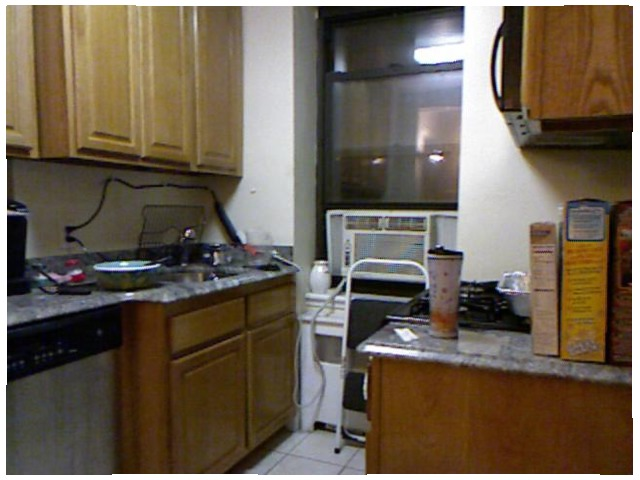<image>
Is the cup in front of the stove? Yes. The cup is positioned in front of the stove, appearing closer to the camera viewpoint. Is there a step stool in front of the ac unit? Yes. The step stool is positioned in front of the ac unit, appearing closer to the camera viewpoint. Is the cabinet to the left of the air conditioner? Yes. From this viewpoint, the cabinet is positioned to the left side relative to the air conditioner. 